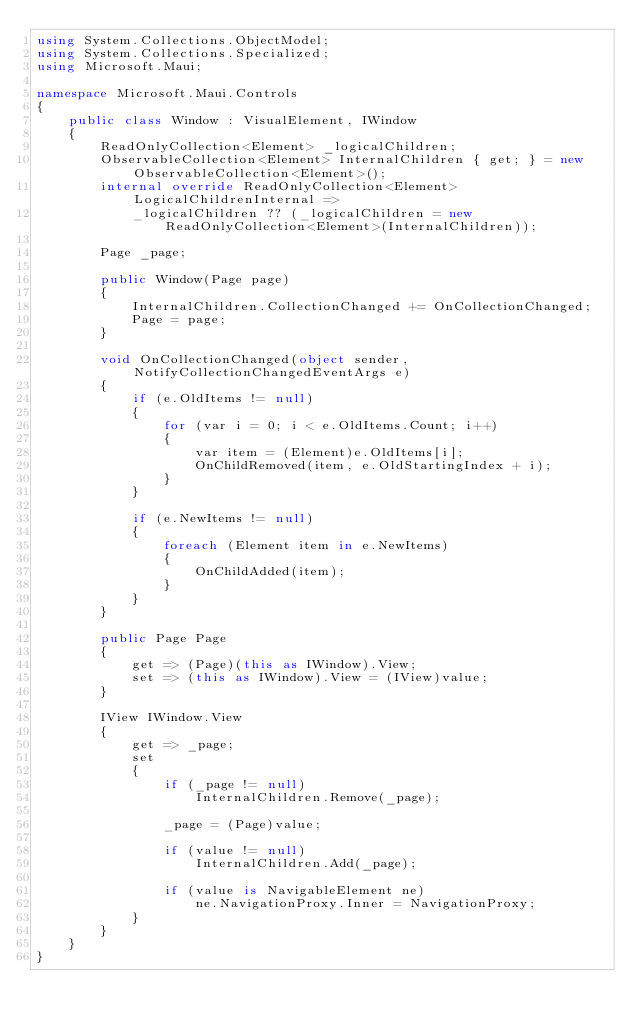<code> <loc_0><loc_0><loc_500><loc_500><_C#_>using System.Collections.ObjectModel;
using System.Collections.Specialized;
using Microsoft.Maui;

namespace Microsoft.Maui.Controls
{
	public class Window : VisualElement, IWindow
	{
		ReadOnlyCollection<Element> _logicalChildren;
		ObservableCollection<Element> InternalChildren { get; } = new ObservableCollection<Element>();
		internal override ReadOnlyCollection<Element> LogicalChildrenInternal =>
			_logicalChildren ?? (_logicalChildren = new ReadOnlyCollection<Element>(InternalChildren));

		Page _page;

		public Window(Page page)
		{
			InternalChildren.CollectionChanged += OnCollectionChanged;
			Page = page;
		}

		void OnCollectionChanged(object sender, NotifyCollectionChangedEventArgs e)
		{
			if (e.OldItems != null)
			{
				for (var i = 0; i < e.OldItems.Count; i++)
				{
					var item = (Element)e.OldItems[i];
					OnChildRemoved(item, e.OldStartingIndex + i);
				}
			}

			if (e.NewItems != null)
			{
				foreach (Element item in e.NewItems)
				{
					OnChildAdded(item);
				}
			}
		}

		public Page Page
		{
			get => (Page)(this as IWindow).View;
			set => (this as IWindow).View = (IView)value;
		}

		IView IWindow.View
		{
			get => _page;
			set
			{
				if (_page != null)
					InternalChildren.Remove(_page);

				_page = (Page)value;

				if (value != null)
					InternalChildren.Add(_page);

				if (value is NavigableElement ne)
					ne.NavigationProxy.Inner = NavigationProxy;
			}
		}
	}
}</code> 